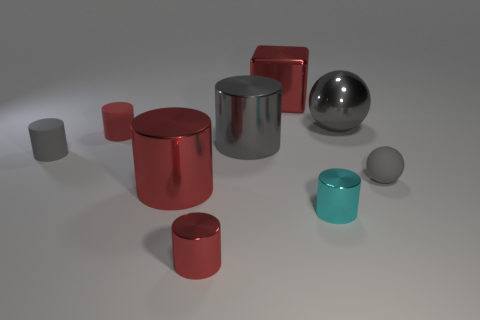What shape is the rubber thing that is the same color as the block?
Make the answer very short. Cylinder. How many small red things are on the left side of the tiny gray rubber thing on the left side of the big metallic object behind the gray metallic ball?
Your answer should be compact. 0. There is a gray object on the left side of the large red object that is in front of the red shiny block; how big is it?
Provide a short and direct response. Small. There is a gray sphere that is the same material as the small gray cylinder; what is its size?
Your response must be concise. Small. There is a shiny thing that is both to the right of the block and in front of the shiny ball; what shape is it?
Make the answer very short. Cylinder. Is the number of metallic objects that are on the left side of the cyan object the same as the number of big cyan shiny spheres?
Offer a terse response. No. How many things are either tiny metallic cylinders or big shiny objects that are in front of the small ball?
Your response must be concise. 3. Is there another tiny object that has the same shape as the red rubber object?
Provide a short and direct response. Yes. Are there the same number of large red metallic objects that are behind the metal cube and small matte things that are behind the large metal ball?
Your answer should be very brief. Yes. Are there any other things that are the same size as the red cube?
Provide a succinct answer. Yes. 